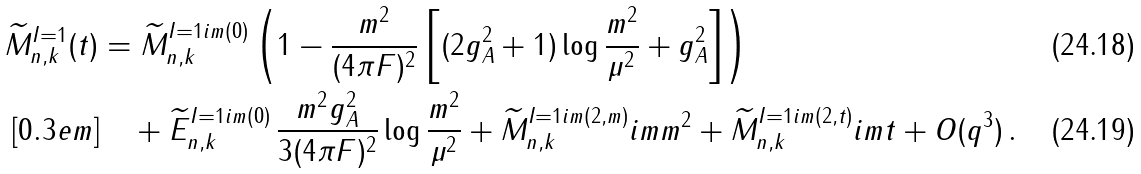<formula> <loc_0><loc_0><loc_500><loc_500>\widetilde { M } _ { n , k } ^ { I = 1 } ( t ) & = \widetilde { M } _ { n , k } ^ { I = 1 \sl i m ( 0 ) } \left ( 1 - \frac { m ^ { 2 } } { ( 4 \pi F ) ^ { 2 } } \left [ ( 2 g _ { A } ^ { 2 } + 1 ) \log \frac { m ^ { 2 } } { \mu ^ { 2 } } + { g _ { A } ^ { 2 } } \right ] \right ) \\ [ 0 . 3 e m ] & \quad + \widetilde { E } _ { n , k } ^ { I = 1 \sl i m ( 0 ) } \, \frac { m ^ { 2 } g _ { A } ^ { 2 } } { 3 ( 4 \pi F ) ^ { 2 } } \log \frac { m ^ { 2 } } { \mu ^ { 2 } } + \widetilde { M } _ { n , k } ^ { I = 1 \sl i m ( 2 , m ) } \sl i m m ^ { 2 } + \widetilde { M } _ { n , k } ^ { I = 1 \sl i m ( 2 , t ) } \sl i m t + O ( q ^ { 3 } ) \, .</formula> 